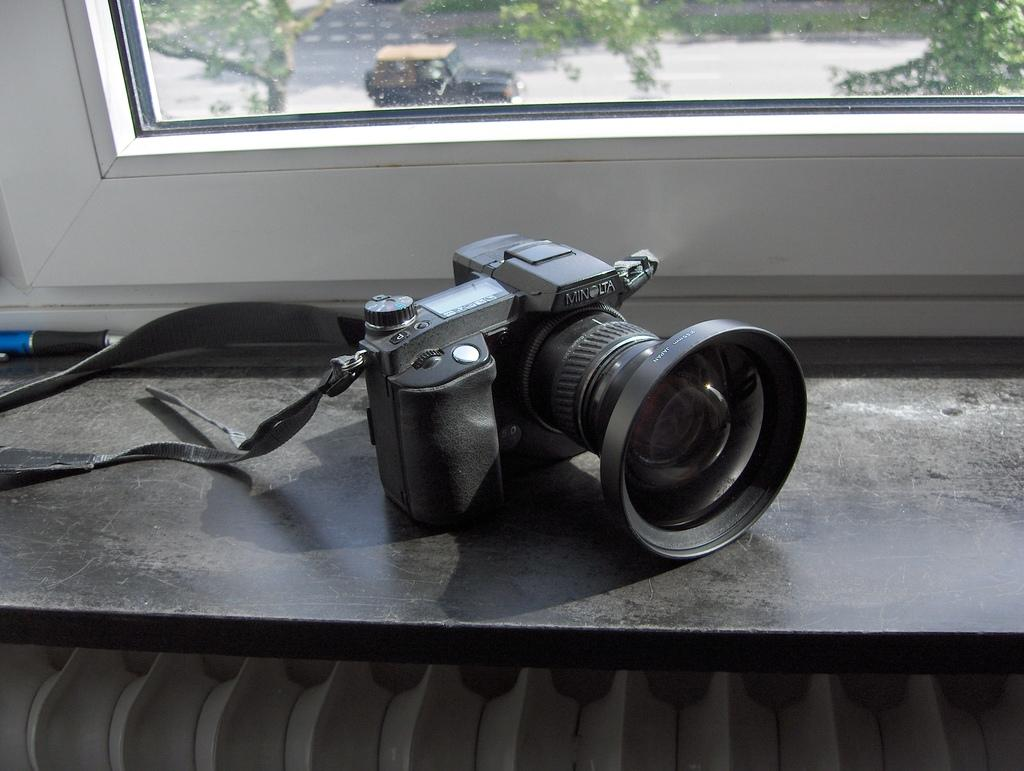What object can be seen in the image that is used for capturing images? There is a camera in the image. What writing instrument is present in the image? There is a pen in the image. What feature of the room is visible in the image? There is a window in the image. What can be seen outside the window in the image? Trees and a vehicle on the road are visible through the window. How many flowers are on the camera in the image? There are no flowers present on the camera in the image. 